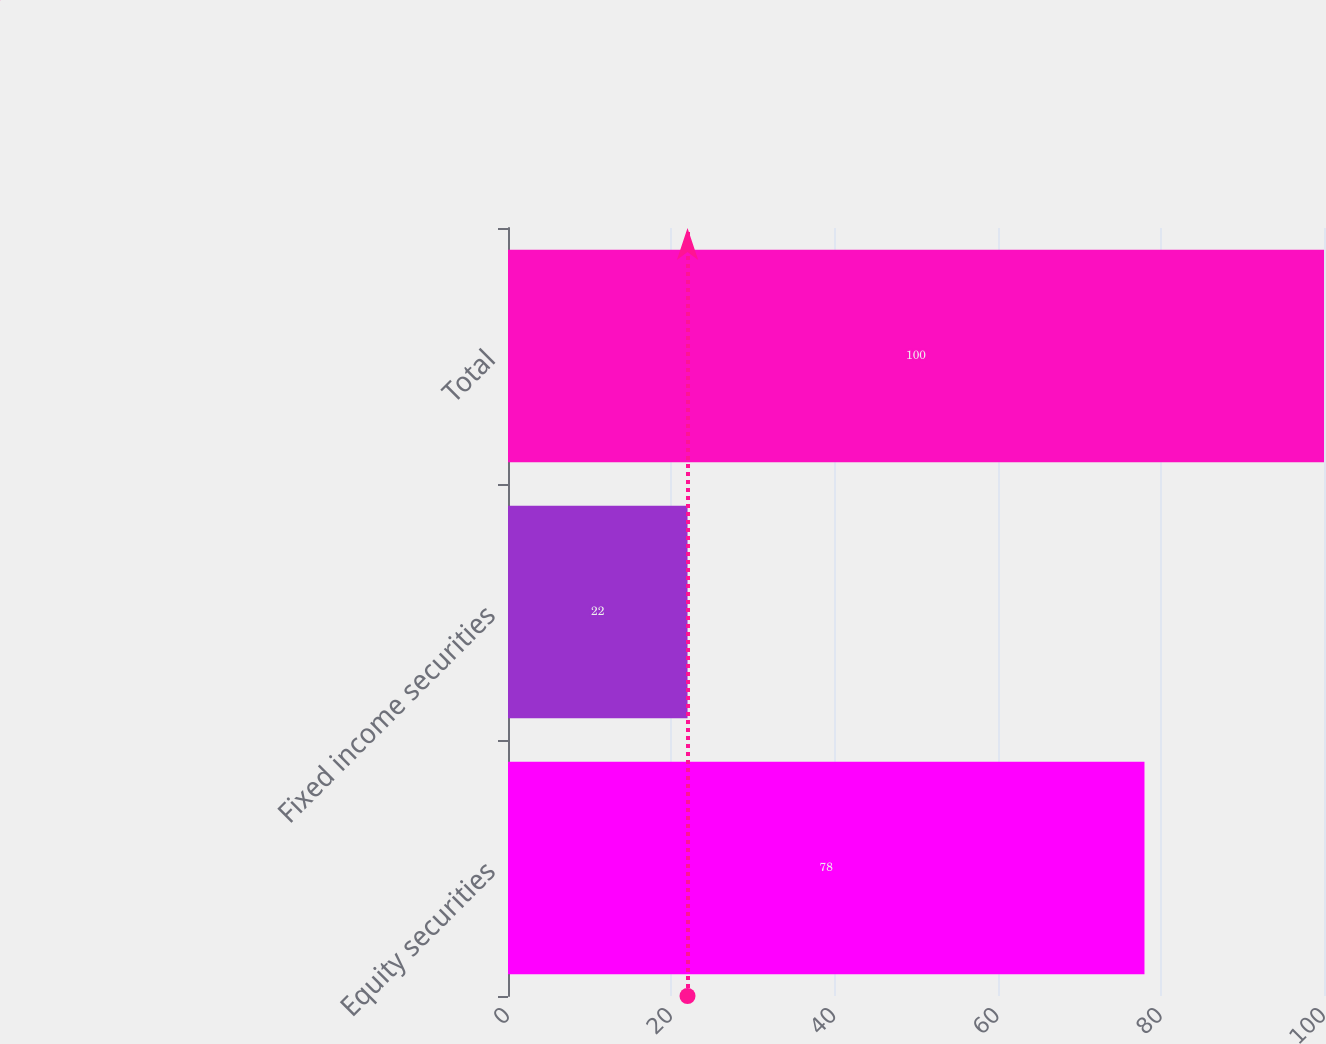Convert chart. <chart><loc_0><loc_0><loc_500><loc_500><bar_chart><fcel>Equity securities<fcel>Fixed income securities<fcel>Total<nl><fcel>78<fcel>22<fcel>100<nl></chart> 